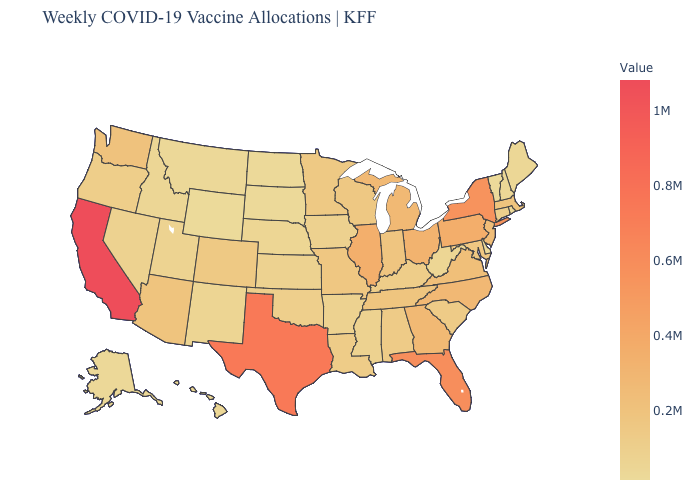Does Vermont have the lowest value in the Northeast?
Be succinct. Yes. Which states have the lowest value in the MidWest?
Keep it brief. North Dakota. Among the states that border California , which have the lowest value?
Be succinct. Nevada. Which states have the lowest value in the Northeast?
Be succinct. Vermont. Does Montana have a lower value than Washington?
Answer briefly. Yes. 